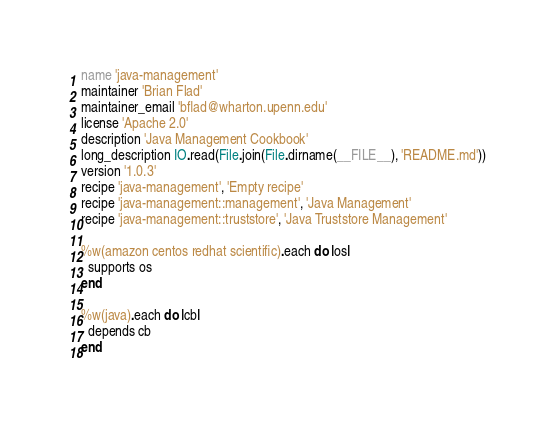Convert code to text. <code><loc_0><loc_0><loc_500><loc_500><_Ruby_>name 'java-management'
maintainer 'Brian Flad'
maintainer_email 'bflad@wharton.upenn.edu'
license 'Apache 2.0'
description 'Java Management Cookbook'
long_description IO.read(File.join(File.dirname(__FILE__), 'README.md'))
version '1.0.3'
recipe 'java-management', 'Empty recipe'
recipe 'java-management::management', 'Java Management'
recipe 'java-management::truststore', 'Java Truststore Management'

%w(amazon centos redhat scientific).each do |os|
  supports os
end

%w(java).each do |cb|
  depends cb
end
</code> 